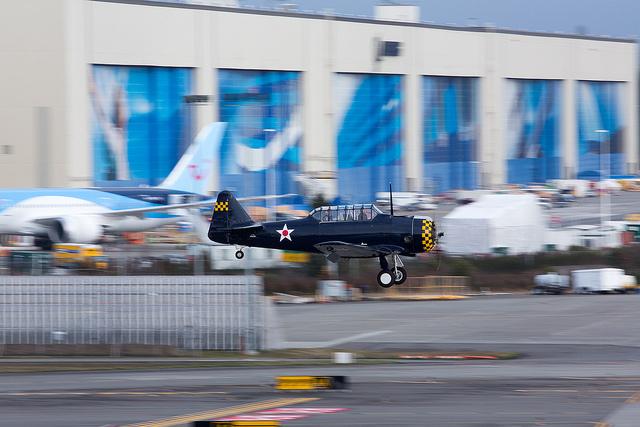Are there advertisements?
Be succinct. No. Is the picture blurry?
Give a very brief answer. Yes. What color is the center of star on the black airplane?
Give a very brief answer. Red. 